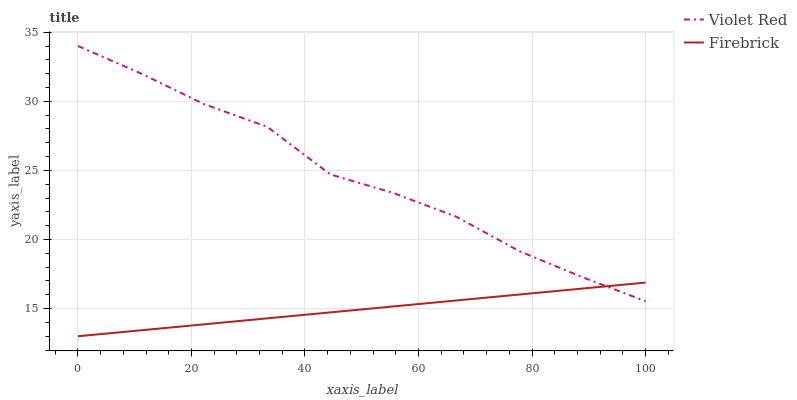Does Firebrick have the minimum area under the curve?
Answer yes or no. Yes. Does Violet Red have the maximum area under the curve?
Answer yes or no. Yes. Does Firebrick have the maximum area under the curve?
Answer yes or no. No. Is Firebrick the smoothest?
Answer yes or no. Yes. Is Violet Red the roughest?
Answer yes or no. Yes. Is Firebrick the roughest?
Answer yes or no. No. Does Firebrick have the lowest value?
Answer yes or no. Yes. Does Violet Red have the highest value?
Answer yes or no. Yes. Does Firebrick have the highest value?
Answer yes or no. No. Does Firebrick intersect Violet Red?
Answer yes or no. Yes. Is Firebrick less than Violet Red?
Answer yes or no. No. Is Firebrick greater than Violet Red?
Answer yes or no. No. 